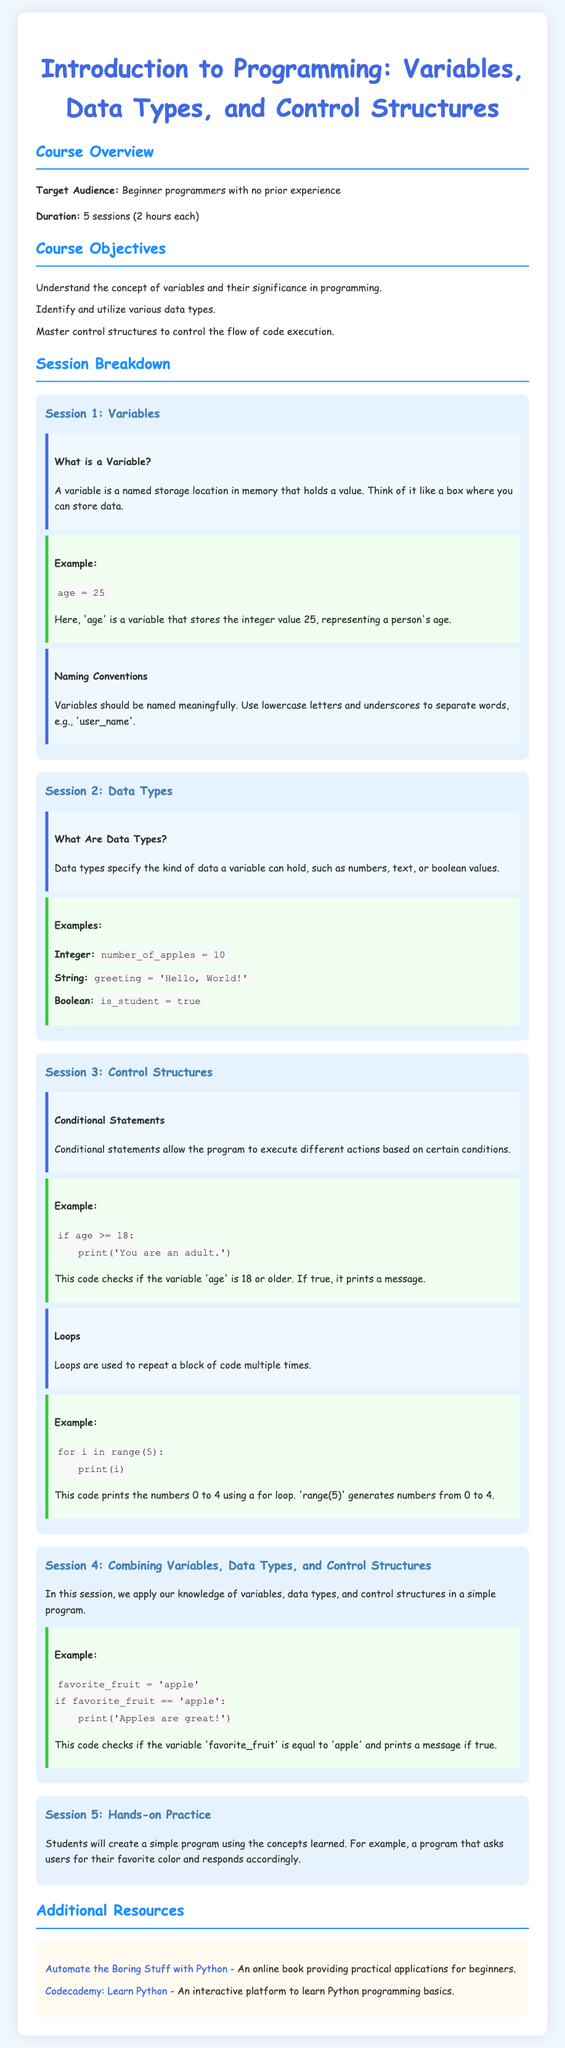What is the target audience for the course? The target audience is specified in the document, describing the participants of the course.
Answer: Beginner programmers with no prior experience How many sessions are included in the course? The course duration is explicitly mentioned in the document as the number of sessions available.
Answer: 5 sessions What is a variable? The document provides a definition of a variable as part of the lesson on variables.
Answer: A named storage location in memory that holds a value What should variable names utilize according to the naming conventions? The document mentions specific guidelines for naming variables effectively.
Answer: Lowercase letters and underscores What type of data does the example 'is_student = true' represent? The document categorizes various data types and provides specific instances for each.
Answer: Boolean What is the function of conditional statements? The document outlines the purpose of conditional statements within programming.
Answer: Allow different actions based on conditions Which session focuses on hands-on practice? The document systematically lists sessions, indicating their specific focus areas.
Answer: Session 5 What is the example given for loops in the course? The document includes an illustrative example to explain the concept of loops.
Answer: for i in range(5): print(i) What additional resource is provided for learning Python? The document lists external resources aimed at supporting learning beyond the provided course material.
Answer: Automate the Boring Stuff with Python 